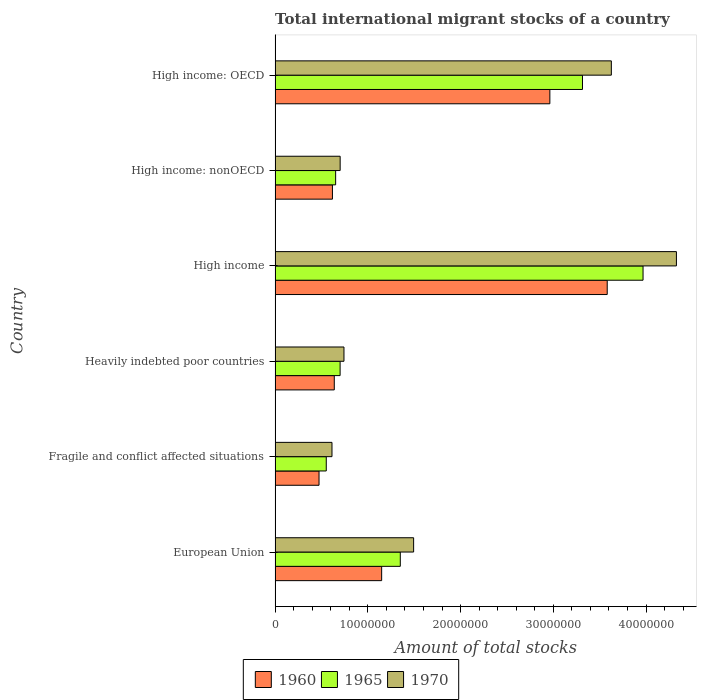How many different coloured bars are there?
Provide a short and direct response. 3. How many groups of bars are there?
Give a very brief answer. 6. Are the number of bars per tick equal to the number of legend labels?
Keep it short and to the point. Yes. Are the number of bars on each tick of the Y-axis equal?
Your answer should be compact. Yes. How many bars are there on the 6th tick from the top?
Offer a very short reply. 3. In how many cases, is the number of bars for a given country not equal to the number of legend labels?
Ensure brevity in your answer.  0. What is the amount of total stocks in in 1965 in High income: OECD?
Ensure brevity in your answer.  3.31e+07. Across all countries, what is the maximum amount of total stocks in in 1970?
Make the answer very short. 4.33e+07. Across all countries, what is the minimum amount of total stocks in in 1970?
Ensure brevity in your answer.  6.14e+06. In which country was the amount of total stocks in in 1960 minimum?
Ensure brevity in your answer.  Fragile and conflict affected situations. What is the total amount of total stocks in in 1960 in the graph?
Your answer should be compact. 9.42e+07. What is the difference between the amount of total stocks in in 1965 in Fragile and conflict affected situations and that in Heavily indebted poor countries?
Ensure brevity in your answer.  -1.49e+06. What is the difference between the amount of total stocks in in 1965 in European Union and the amount of total stocks in in 1960 in Fragile and conflict affected situations?
Keep it short and to the point. 8.76e+06. What is the average amount of total stocks in in 1960 per country?
Provide a succinct answer. 1.57e+07. What is the difference between the amount of total stocks in in 1960 and amount of total stocks in in 1970 in Heavily indebted poor countries?
Keep it short and to the point. -1.04e+06. In how many countries, is the amount of total stocks in in 1970 greater than 32000000 ?
Provide a short and direct response. 2. What is the ratio of the amount of total stocks in in 1970 in High income to that in High income: nonOECD?
Give a very brief answer. 6.17. Is the amount of total stocks in in 1970 in Heavily indebted poor countries less than that in High income?
Your answer should be compact. Yes. What is the difference between the highest and the second highest amount of total stocks in in 1960?
Ensure brevity in your answer.  6.18e+06. What is the difference between the highest and the lowest amount of total stocks in in 1960?
Your answer should be very brief. 3.11e+07. Is the sum of the amount of total stocks in in 1970 in European Union and High income: nonOECD greater than the maximum amount of total stocks in in 1965 across all countries?
Offer a terse response. No. How many bars are there?
Ensure brevity in your answer.  18. Are all the bars in the graph horizontal?
Offer a very short reply. Yes. What is the difference between two consecutive major ticks on the X-axis?
Offer a very short reply. 1.00e+07. Does the graph contain any zero values?
Give a very brief answer. No. Where does the legend appear in the graph?
Give a very brief answer. Bottom center. How many legend labels are there?
Provide a succinct answer. 3. How are the legend labels stacked?
Give a very brief answer. Horizontal. What is the title of the graph?
Offer a very short reply. Total international migrant stocks of a country. Does "1980" appear as one of the legend labels in the graph?
Your answer should be compact. No. What is the label or title of the X-axis?
Keep it short and to the point. Amount of total stocks. What is the Amount of total stocks of 1960 in European Union?
Provide a short and direct response. 1.15e+07. What is the Amount of total stocks of 1965 in European Union?
Make the answer very short. 1.35e+07. What is the Amount of total stocks in 1970 in European Union?
Provide a succinct answer. 1.49e+07. What is the Amount of total stocks in 1960 in Fragile and conflict affected situations?
Keep it short and to the point. 4.74e+06. What is the Amount of total stocks of 1965 in Fragile and conflict affected situations?
Give a very brief answer. 5.52e+06. What is the Amount of total stocks of 1970 in Fragile and conflict affected situations?
Your answer should be compact. 6.14e+06. What is the Amount of total stocks of 1960 in Heavily indebted poor countries?
Your answer should be very brief. 6.38e+06. What is the Amount of total stocks of 1965 in Heavily indebted poor countries?
Your answer should be compact. 7.01e+06. What is the Amount of total stocks of 1970 in Heavily indebted poor countries?
Make the answer very short. 7.43e+06. What is the Amount of total stocks in 1960 in High income?
Your response must be concise. 3.58e+07. What is the Amount of total stocks of 1965 in High income?
Your response must be concise. 3.97e+07. What is the Amount of total stocks in 1970 in High income?
Offer a very short reply. 4.33e+07. What is the Amount of total stocks in 1960 in High income: nonOECD?
Make the answer very short. 6.18e+06. What is the Amount of total stocks of 1965 in High income: nonOECD?
Keep it short and to the point. 6.53e+06. What is the Amount of total stocks in 1970 in High income: nonOECD?
Your answer should be compact. 7.02e+06. What is the Amount of total stocks in 1960 in High income: OECD?
Your answer should be very brief. 2.96e+07. What is the Amount of total stocks of 1965 in High income: OECD?
Ensure brevity in your answer.  3.31e+07. What is the Amount of total stocks in 1970 in High income: OECD?
Keep it short and to the point. 3.63e+07. Across all countries, what is the maximum Amount of total stocks in 1960?
Give a very brief answer. 3.58e+07. Across all countries, what is the maximum Amount of total stocks in 1965?
Your answer should be very brief. 3.97e+07. Across all countries, what is the maximum Amount of total stocks of 1970?
Offer a very short reply. 4.33e+07. Across all countries, what is the minimum Amount of total stocks of 1960?
Provide a succinct answer. 4.74e+06. Across all countries, what is the minimum Amount of total stocks of 1965?
Ensure brevity in your answer.  5.52e+06. Across all countries, what is the minimum Amount of total stocks of 1970?
Offer a very short reply. 6.14e+06. What is the total Amount of total stocks of 1960 in the graph?
Keep it short and to the point. 9.42e+07. What is the total Amount of total stocks in 1965 in the graph?
Make the answer very short. 1.05e+08. What is the total Amount of total stocks of 1970 in the graph?
Your response must be concise. 1.15e+08. What is the difference between the Amount of total stocks in 1960 in European Union and that in Fragile and conflict affected situations?
Your answer should be very brief. 6.75e+06. What is the difference between the Amount of total stocks in 1965 in European Union and that in Fragile and conflict affected situations?
Give a very brief answer. 7.98e+06. What is the difference between the Amount of total stocks in 1970 in European Union and that in Fragile and conflict affected situations?
Your answer should be very brief. 8.80e+06. What is the difference between the Amount of total stocks in 1960 in European Union and that in Heavily indebted poor countries?
Make the answer very short. 5.11e+06. What is the difference between the Amount of total stocks of 1965 in European Union and that in Heavily indebted poor countries?
Offer a terse response. 6.49e+06. What is the difference between the Amount of total stocks of 1970 in European Union and that in Heavily indebted poor countries?
Ensure brevity in your answer.  7.51e+06. What is the difference between the Amount of total stocks of 1960 in European Union and that in High income?
Your answer should be very brief. -2.43e+07. What is the difference between the Amount of total stocks of 1965 in European Union and that in High income?
Provide a short and direct response. -2.62e+07. What is the difference between the Amount of total stocks of 1970 in European Union and that in High income?
Offer a terse response. -2.83e+07. What is the difference between the Amount of total stocks of 1960 in European Union and that in High income: nonOECD?
Give a very brief answer. 5.31e+06. What is the difference between the Amount of total stocks in 1965 in European Union and that in High income: nonOECD?
Your answer should be compact. 6.97e+06. What is the difference between the Amount of total stocks of 1970 in European Union and that in High income: nonOECD?
Your answer should be compact. 7.92e+06. What is the difference between the Amount of total stocks in 1960 in European Union and that in High income: OECD?
Ensure brevity in your answer.  -1.81e+07. What is the difference between the Amount of total stocks of 1965 in European Union and that in High income: OECD?
Your answer should be compact. -1.96e+07. What is the difference between the Amount of total stocks of 1970 in European Union and that in High income: OECD?
Keep it short and to the point. -2.13e+07. What is the difference between the Amount of total stocks in 1960 in Fragile and conflict affected situations and that in Heavily indebted poor countries?
Offer a very short reply. -1.64e+06. What is the difference between the Amount of total stocks of 1965 in Fragile and conflict affected situations and that in Heavily indebted poor countries?
Your response must be concise. -1.49e+06. What is the difference between the Amount of total stocks in 1970 in Fragile and conflict affected situations and that in Heavily indebted poor countries?
Provide a succinct answer. -1.29e+06. What is the difference between the Amount of total stocks of 1960 in Fragile and conflict affected situations and that in High income?
Ensure brevity in your answer.  -3.11e+07. What is the difference between the Amount of total stocks of 1965 in Fragile and conflict affected situations and that in High income?
Give a very brief answer. -3.42e+07. What is the difference between the Amount of total stocks in 1970 in Fragile and conflict affected situations and that in High income?
Provide a succinct answer. -3.71e+07. What is the difference between the Amount of total stocks in 1960 in Fragile and conflict affected situations and that in High income: nonOECD?
Your answer should be very brief. -1.44e+06. What is the difference between the Amount of total stocks in 1965 in Fragile and conflict affected situations and that in High income: nonOECD?
Ensure brevity in your answer.  -1.01e+06. What is the difference between the Amount of total stocks of 1970 in Fragile and conflict affected situations and that in High income: nonOECD?
Provide a short and direct response. -8.82e+05. What is the difference between the Amount of total stocks of 1960 in Fragile and conflict affected situations and that in High income: OECD?
Offer a very short reply. -2.49e+07. What is the difference between the Amount of total stocks in 1965 in Fragile and conflict affected situations and that in High income: OECD?
Provide a succinct answer. -2.76e+07. What is the difference between the Amount of total stocks in 1970 in Fragile and conflict affected situations and that in High income: OECD?
Make the answer very short. -3.01e+07. What is the difference between the Amount of total stocks of 1960 in Heavily indebted poor countries and that in High income?
Offer a terse response. -2.94e+07. What is the difference between the Amount of total stocks of 1965 in Heavily indebted poor countries and that in High income?
Make the answer very short. -3.27e+07. What is the difference between the Amount of total stocks of 1970 in Heavily indebted poor countries and that in High income?
Your response must be concise. -3.59e+07. What is the difference between the Amount of total stocks in 1960 in Heavily indebted poor countries and that in High income: nonOECD?
Your response must be concise. 2.00e+05. What is the difference between the Amount of total stocks in 1965 in Heavily indebted poor countries and that in High income: nonOECD?
Offer a terse response. 4.82e+05. What is the difference between the Amount of total stocks of 1970 in Heavily indebted poor countries and that in High income: nonOECD?
Ensure brevity in your answer.  4.10e+05. What is the difference between the Amount of total stocks in 1960 in Heavily indebted poor countries and that in High income: OECD?
Give a very brief answer. -2.32e+07. What is the difference between the Amount of total stocks of 1965 in Heavily indebted poor countries and that in High income: OECD?
Your answer should be compact. -2.61e+07. What is the difference between the Amount of total stocks in 1970 in Heavily indebted poor countries and that in High income: OECD?
Keep it short and to the point. -2.88e+07. What is the difference between the Amount of total stocks of 1960 in High income and that in High income: nonOECD?
Provide a short and direct response. 2.96e+07. What is the difference between the Amount of total stocks in 1965 in High income and that in High income: nonOECD?
Ensure brevity in your answer.  3.31e+07. What is the difference between the Amount of total stocks of 1970 in High income and that in High income: nonOECD?
Keep it short and to the point. 3.63e+07. What is the difference between the Amount of total stocks in 1960 in High income and that in High income: OECD?
Your response must be concise. 6.18e+06. What is the difference between the Amount of total stocks of 1965 in High income and that in High income: OECD?
Provide a succinct answer. 6.53e+06. What is the difference between the Amount of total stocks of 1970 in High income and that in High income: OECD?
Make the answer very short. 7.02e+06. What is the difference between the Amount of total stocks of 1960 in High income: nonOECD and that in High income: OECD?
Offer a terse response. -2.34e+07. What is the difference between the Amount of total stocks in 1965 in High income: nonOECD and that in High income: OECD?
Offer a very short reply. -2.66e+07. What is the difference between the Amount of total stocks in 1970 in High income: nonOECD and that in High income: OECD?
Offer a very short reply. -2.92e+07. What is the difference between the Amount of total stocks in 1960 in European Union and the Amount of total stocks in 1965 in Fragile and conflict affected situations?
Make the answer very short. 5.97e+06. What is the difference between the Amount of total stocks in 1960 in European Union and the Amount of total stocks in 1970 in Fragile and conflict affected situations?
Provide a short and direct response. 5.36e+06. What is the difference between the Amount of total stocks of 1965 in European Union and the Amount of total stocks of 1970 in Fragile and conflict affected situations?
Make the answer very short. 7.37e+06. What is the difference between the Amount of total stocks in 1960 in European Union and the Amount of total stocks in 1965 in Heavily indebted poor countries?
Offer a terse response. 4.48e+06. What is the difference between the Amount of total stocks of 1960 in European Union and the Amount of total stocks of 1970 in Heavily indebted poor countries?
Provide a short and direct response. 4.06e+06. What is the difference between the Amount of total stocks of 1965 in European Union and the Amount of total stocks of 1970 in Heavily indebted poor countries?
Your answer should be very brief. 6.08e+06. What is the difference between the Amount of total stocks of 1960 in European Union and the Amount of total stocks of 1965 in High income?
Your answer should be compact. -2.82e+07. What is the difference between the Amount of total stocks of 1960 in European Union and the Amount of total stocks of 1970 in High income?
Provide a succinct answer. -3.18e+07. What is the difference between the Amount of total stocks in 1965 in European Union and the Amount of total stocks in 1970 in High income?
Provide a short and direct response. -2.98e+07. What is the difference between the Amount of total stocks of 1960 in European Union and the Amount of total stocks of 1965 in High income: nonOECD?
Your answer should be very brief. 4.96e+06. What is the difference between the Amount of total stocks in 1960 in European Union and the Amount of total stocks in 1970 in High income: nonOECD?
Your answer should be very brief. 4.47e+06. What is the difference between the Amount of total stocks in 1965 in European Union and the Amount of total stocks in 1970 in High income: nonOECD?
Give a very brief answer. 6.48e+06. What is the difference between the Amount of total stocks in 1960 in European Union and the Amount of total stocks in 1965 in High income: OECD?
Give a very brief answer. -2.17e+07. What is the difference between the Amount of total stocks of 1960 in European Union and the Amount of total stocks of 1970 in High income: OECD?
Make the answer very short. -2.48e+07. What is the difference between the Amount of total stocks of 1965 in European Union and the Amount of total stocks of 1970 in High income: OECD?
Provide a short and direct response. -2.28e+07. What is the difference between the Amount of total stocks of 1960 in Fragile and conflict affected situations and the Amount of total stocks of 1965 in Heavily indebted poor countries?
Ensure brevity in your answer.  -2.27e+06. What is the difference between the Amount of total stocks of 1960 in Fragile and conflict affected situations and the Amount of total stocks of 1970 in Heavily indebted poor countries?
Give a very brief answer. -2.69e+06. What is the difference between the Amount of total stocks of 1965 in Fragile and conflict affected situations and the Amount of total stocks of 1970 in Heavily indebted poor countries?
Provide a short and direct response. -1.91e+06. What is the difference between the Amount of total stocks of 1960 in Fragile and conflict affected situations and the Amount of total stocks of 1965 in High income?
Your response must be concise. -3.49e+07. What is the difference between the Amount of total stocks in 1960 in Fragile and conflict affected situations and the Amount of total stocks in 1970 in High income?
Make the answer very short. -3.85e+07. What is the difference between the Amount of total stocks in 1965 in Fragile and conflict affected situations and the Amount of total stocks in 1970 in High income?
Ensure brevity in your answer.  -3.78e+07. What is the difference between the Amount of total stocks of 1960 in Fragile and conflict affected situations and the Amount of total stocks of 1965 in High income: nonOECD?
Keep it short and to the point. -1.79e+06. What is the difference between the Amount of total stocks of 1960 in Fragile and conflict affected situations and the Amount of total stocks of 1970 in High income: nonOECD?
Keep it short and to the point. -2.28e+06. What is the difference between the Amount of total stocks in 1965 in Fragile and conflict affected situations and the Amount of total stocks in 1970 in High income: nonOECD?
Make the answer very short. -1.50e+06. What is the difference between the Amount of total stocks in 1960 in Fragile and conflict affected situations and the Amount of total stocks in 1965 in High income: OECD?
Offer a very short reply. -2.84e+07. What is the difference between the Amount of total stocks of 1960 in Fragile and conflict affected situations and the Amount of total stocks of 1970 in High income: OECD?
Your answer should be compact. -3.15e+07. What is the difference between the Amount of total stocks in 1965 in Fragile and conflict affected situations and the Amount of total stocks in 1970 in High income: OECD?
Provide a succinct answer. -3.07e+07. What is the difference between the Amount of total stocks of 1960 in Heavily indebted poor countries and the Amount of total stocks of 1965 in High income?
Offer a very short reply. -3.33e+07. What is the difference between the Amount of total stocks of 1960 in Heavily indebted poor countries and the Amount of total stocks of 1970 in High income?
Give a very brief answer. -3.69e+07. What is the difference between the Amount of total stocks in 1965 in Heavily indebted poor countries and the Amount of total stocks in 1970 in High income?
Keep it short and to the point. -3.63e+07. What is the difference between the Amount of total stocks in 1960 in Heavily indebted poor countries and the Amount of total stocks in 1965 in High income: nonOECD?
Provide a succinct answer. -1.46e+05. What is the difference between the Amount of total stocks in 1960 in Heavily indebted poor countries and the Amount of total stocks in 1970 in High income: nonOECD?
Keep it short and to the point. -6.34e+05. What is the difference between the Amount of total stocks in 1965 in Heavily indebted poor countries and the Amount of total stocks in 1970 in High income: nonOECD?
Offer a very short reply. -5219. What is the difference between the Amount of total stocks in 1960 in Heavily indebted poor countries and the Amount of total stocks in 1965 in High income: OECD?
Your response must be concise. -2.68e+07. What is the difference between the Amount of total stocks of 1960 in Heavily indebted poor countries and the Amount of total stocks of 1970 in High income: OECD?
Your response must be concise. -2.99e+07. What is the difference between the Amount of total stocks in 1965 in Heavily indebted poor countries and the Amount of total stocks in 1970 in High income: OECD?
Ensure brevity in your answer.  -2.92e+07. What is the difference between the Amount of total stocks in 1960 in High income and the Amount of total stocks in 1965 in High income: nonOECD?
Your response must be concise. 2.93e+07. What is the difference between the Amount of total stocks in 1960 in High income and the Amount of total stocks in 1970 in High income: nonOECD?
Offer a terse response. 2.88e+07. What is the difference between the Amount of total stocks in 1965 in High income and the Amount of total stocks in 1970 in High income: nonOECD?
Provide a succinct answer. 3.27e+07. What is the difference between the Amount of total stocks in 1960 in High income and the Amount of total stocks in 1965 in High income: OECD?
Provide a succinct answer. 2.67e+06. What is the difference between the Amount of total stocks of 1960 in High income and the Amount of total stocks of 1970 in High income: OECD?
Offer a terse response. -4.45e+05. What is the difference between the Amount of total stocks of 1965 in High income and the Amount of total stocks of 1970 in High income: OECD?
Offer a very short reply. 3.42e+06. What is the difference between the Amount of total stocks in 1960 in High income: nonOECD and the Amount of total stocks in 1965 in High income: OECD?
Provide a short and direct response. -2.70e+07. What is the difference between the Amount of total stocks in 1960 in High income: nonOECD and the Amount of total stocks in 1970 in High income: OECD?
Your answer should be compact. -3.01e+07. What is the difference between the Amount of total stocks in 1965 in High income: nonOECD and the Amount of total stocks in 1970 in High income: OECD?
Your answer should be compact. -2.97e+07. What is the average Amount of total stocks in 1960 per country?
Keep it short and to the point. 1.57e+07. What is the average Amount of total stocks of 1965 per country?
Keep it short and to the point. 1.76e+07. What is the average Amount of total stocks of 1970 per country?
Make the answer very short. 1.92e+07. What is the difference between the Amount of total stocks of 1960 and Amount of total stocks of 1965 in European Union?
Ensure brevity in your answer.  -2.01e+06. What is the difference between the Amount of total stocks of 1960 and Amount of total stocks of 1970 in European Union?
Make the answer very short. -3.45e+06. What is the difference between the Amount of total stocks in 1965 and Amount of total stocks in 1970 in European Union?
Provide a succinct answer. -1.44e+06. What is the difference between the Amount of total stocks in 1960 and Amount of total stocks in 1965 in Fragile and conflict affected situations?
Give a very brief answer. -7.79e+05. What is the difference between the Amount of total stocks in 1960 and Amount of total stocks in 1970 in Fragile and conflict affected situations?
Provide a short and direct response. -1.40e+06. What is the difference between the Amount of total stocks of 1965 and Amount of total stocks of 1970 in Fragile and conflict affected situations?
Provide a succinct answer. -6.17e+05. What is the difference between the Amount of total stocks in 1960 and Amount of total stocks in 1965 in Heavily indebted poor countries?
Give a very brief answer. -6.28e+05. What is the difference between the Amount of total stocks of 1960 and Amount of total stocks of 1970 in Heavily indebted poor countries?
Provide a succinct answer. -1.04e+06. What is the difference between the Amount of total stocks in 1965 and Amount of total stocks in 1970 in Heavily indebted poor countries?
Offer a terse response. -4.15e+05. What is the difference between the Amount of total stocks in 1960 and Amount of total stocks in 1965 in High income?
Offer a very short reply. -3.86e+06. What is the difference between the Amount of total stocks in 1960 and Amount of total stocks in 1970 in High income?
Offer a terse response. -7.46e+06. What is the difference between the Amount of total stocks of 1965 and Amount of total stocks of 1970 in High income?
Make the answer very short. -3.60e+06. What is the difference between the Amount of total stocks in 1960 and Amount of total stocks in 1965 in High income: nonOECD?
Give a very brief answer. -3.47e+05. What is the difference between the Amount of total stocks of 1960 and Amount of total stocks of 1970 in High income: nonOECD?
Keep it short and to the point. -8.34e+05. What is the difference between the Amount of total stocks of 1965 and Amount of total stocks of 1970 in High income: nonOECD?
Keep it short and to the point. -4.87e+05. What is the difference between the Amount of total stocks of 1960 and Amount of total stocks of 1965 in High income: OECD?
Make the answer very short. -3.52e+06. What is the difference between the Amount of total stocks in 1960 and Amount of total stocks in 1970 in High income: OECD?
Your answer should be compact. -6.63e+06. What is the difference between the Amount of total stocks of 1965 and Amount of total stocks of 1970 in High income: OECD?
Ensure brevity in your answer.  -3.11e+06. What is the ratio of the Amount of total stocks of 1960 in European Union to that in Fragile and conflict affected situations?
Provide a short and direct response. 2.42. What is the ratio of the Amount of total stocks in 1965 in European Union to that in Fragile and conflict affected situations?
Your answer should be compact. 2.45. What is the ratio of the Amount of total stocks in 1970 in European Union to that in Fragile and conflict affected situations?
Keep it short and to the point. 2.43. What is the ratio of the Amount of total stocks in 1960 in European Union to that in Heavily indebted poor countries?
Provide a short and direct response. 1.8. What is the ratio of the Amount of total stocks of 1965 in European Union to that in Heavily indebted poor countries?
Offer a very short reply. 1.93. What is the ratio of the Amount of total stocks in 1970 in European Union to that in Heavily indebted poor countries?
Provide a short and direct response. 2.01. What is the ratio of the Amount of total stocks of 1960 in European Union to that in High income?
Provide a short and direct response. 0.32. What is the ratio of the Amount of total stocks of 1965 in European Union to that in High income?
Provide a succinct answer. 0.34. What is the ratio of the Amount of total stocks of 1970 in European Union to that in High income?
Your answer should be very brief. 0.35. What is the ratio of the Amount of total stocks of 1960 in European Union to that in High income: nonOECD?
Make the answer very short. 1.86. What is the ratio of the Amount of total stocks of 1965 in European Union to that in High income: nonOECD?
Provide a short and direct response. 2.07. What is the ratio of the Amount of total stocks in 1970 in European Union to that in High income: nonOECD?
Make the answer very short. 2.13. What is the ratio of the Amount of total stocks of 1960 in European Union to that in High income: OECD?
Offer a terse response. 0.39. What is the ratio of the Amount of total stocks in 1965 in European Union to that in High income: OECD?
Your answer should be compact. 0.41. What is the ratio of the Amount of total stocks in 1970 in European Union to that in High income: OECD?
Your answer should be very brief. 0.41. What is the ratio of the Amount of total stocks of 1960 in Fragile and conflict affected situations to that in Heavily indebted poor countries?
Offer a terse response. 0.74. What is the ratio of the Amount of total stocks of 1965 in Fragile and conflict affected situations to that in Heavily indebted poor countries?
Your answer should be very brief. 0.79. What is the ratio of the Amount of total stocks in 1970 in Fragile and conflict affected situations to that in Heavily indebted poor countries?
Give a very brief answer. 0.83. What is the ratio of the Amount of total stocks in 1960 in Fragile and conflict affected situations to that in High income?
Provide a succinct answer. 0.13. What is the ratio of the Amount of total stocks in 1965 in Fragile and conflict affected situations to that in High income?
Provide a succinct answer. 0.14. What is the ratio of the Amount of total stocks in 1970 in Fragile and conflict affected situations to that in High income?
Your answer should be very brief. 0.14. What is the ratio of the Amount of total stocks of 1960 in Fragile and conflict affected situations to that in High income: nonOECD?
Give a very brief answer. 0.77. What is the ratio of the Amount of total stocks of 1965 in Fragile and conflict affected situations to that in High income: nonOECD?
Your answer should be very brief. 0.84. What is the ratio of the Amount of total stocks of 1970 in Fragile and conflict affected situations to that in High income: nonOECD?
Make the answer very short. 0.87. What is the ratio of the Amount of total stocks of 1960 in Fragile and conflict affected situations to that in High income: OECD?
Keep it short and to the point. 0.16. What is the ratio of the Amount of total stocks in 1965 in Fragile and conflict affected situations to that in High income: OECD?
Keep it short and to the point. 0.17. What is the ratio of the Amount of total stocks in 1970 in Fragile and conflict affected situations to that in High income: OECD?
Ensure brevity in your answer.  0.17. What is the ratio of the Amount of total stocks in 1960 in Heavily indebted poor countries to that in High income?
Provide a short and direct response. 0.18. What is the ratio of the Amount of total stocks of 1965 in Heavily indebted poor countries to that in High income?
Your answer should be very brief. 0.18. What is the ratio of the Amount of total stocks in 1970 in Heavily indebted poor countries to that in High income?
Give a very brief answer. 0.17. What is the ratio of the Amount of total stocks of 1960 in Heavily indebted poor countries to that in High income: nonOECD?
Give a very brief answer. 1.03. What is the ratio of the Amount of total stocks of 1965 in Heavily indebted poor countries to that in High income: nonOECD?
Provide a succinct answer. 1.07. What is the ratio of the Amount of total stocks of 1970 in Heavily indebted poor countries to that in High income: nonOECD?
Provide a succinct answer. 1.06. What is the ratio of the Amount of total stocks in 1960 in Heavily indebted poor countries to that in High income: OECD?
Provide a succinct answer. 0.22. What is the ratio of the Amount of total stocks of 1965 in Heavily indebted poor countries to that in High income: OECD?
Provide a succinct answer. 0.21. What is the ratio of the Amount of total stocks in 1970 in Heavily indebted poor countries to that in High income: OECD?
Your answer should be very brief. 0.2. What is the ratio of the Amount of total stocks of 1960 in High income to that in High income: nonOECD?
Keep it short and to the point. 5.79. What is the ratio of the Amount of total stocks in 1965 in High income to that in High income: nonOECD?
Offer a very short reply. 6.08. What is the ratio of the Amount of total stocks in 1970 in High income to that in High income: nonOECD?
Your answer should be compact. 6.17. What is the ratio of the Amount of total stocks of 1960 in High income to that in High income: OECD?
Ensure brevity in your answer.  1.21. What is the ratio of the Amount of total stocks in 1965 in High income to that in High income: OECD?
Offer a terse response. 1.2. What is the ratio of the Amount of total stocks in 1970 in High income to that in High income: OECD?
Keep it short and to the point. 1.19. What is the ratio of the Amount of total stocks of 1960 in High income: nonOECD to that in High income: OECD?
Make the answer very short. 0.21. What is the ratio of the Amount of total stocks in 1965 in High income: nonOECD to that in High income: OECD?
Your answer should be very brief. 0.2. What is the ratio of the Amount of total stocks of 1970 in High income: nonOECD to that in High income: OECD?
Provide a short and direct response. 0.19. What is the difference between the highest and the second highest Amount of total stocks in 1960?
Ensure brevity in your answer.  6.18e+06. What is the difference between the highest and the second highest Amount of total stocks of 1965?
Offer a terse response. 6.53e+06. What is the difference between the highest and the second highest Amount of total stocks of 1970?
Provide a short and direct response. 7.02e+06. What is the difference between the highest and the lowest Amount of total stocks in 1960?
Ensure brevity in your answer.  3.11e+07. What is the difference between the highest and the lowest Amount of total stocks in 1965?
Offer a terse response. 3.42e+07. What is the difference between the highest and the lowest Amount of total stocks in 1970?
Make the answer very short. 3.71e+07. 